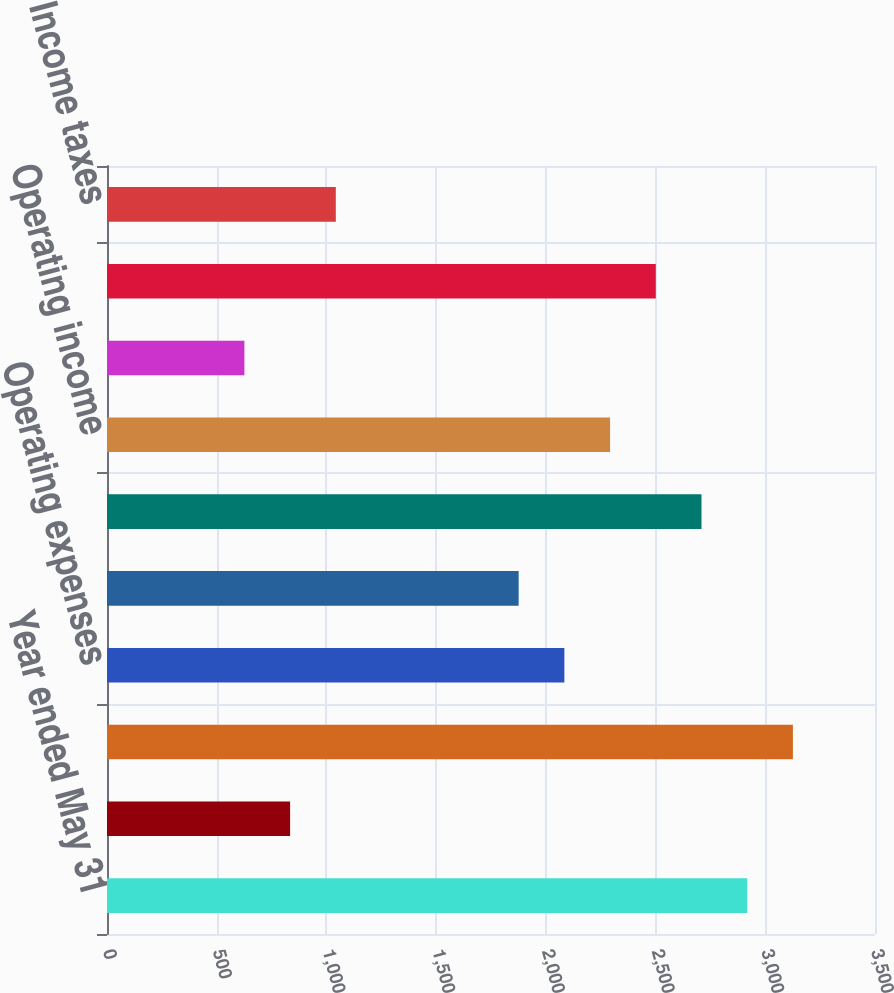Convert chart. <chart><loc_0><loc_0><loc_500><loc_500><bar_chart><fcel>Year ended May 31<fcel>Interest on funds held for<fcel>Total revenue<fcel>Operating expenses<fcel>Selling general and<fcel>Total expenses<fcel>Operating income<fcel>Investment income net<fcel>Income before income taxes<fcel>Income taxes<nl><fcel>2917.58<fcel>834.48<fcel>3125.89<fcel>2084.34<fcel>1876.03<fcel>2709.27<fcel>2292.65<fcel>626.17<fcel>2500.96<fcel>1042.79<nl></chart> 